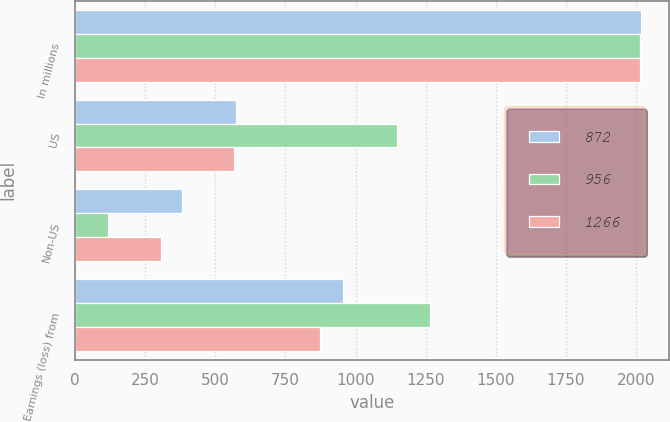Convert chart. <chart><loc_0><loc_0><loc_500><loc_500><stacked_bar_chart><ecel><fcel>In millions<fcel>US<fcel>Non-US<fcel>Earnings (loss) from<nl><fcel>872<fcel>2016<fcel>573<fcel>383<fcel>956<nl><fcel>956<fcel>2015<fcel>1147<fcel>119<fcel>1266<nl><fcel>1266<fcel>2014<fcel>565<fcel>307<fcel>872<nl></chart> 